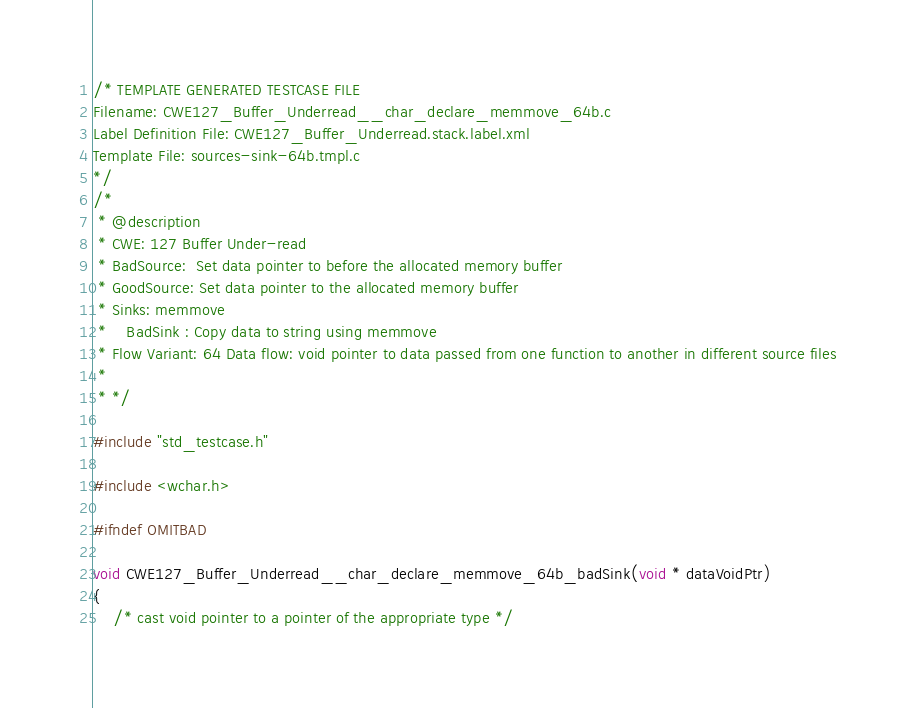<code> <loc_0><loc_0><loc_500><loc_500><_C_>/* TEMPLATE GENERATED TESTCASE FILE
Filename: CWE127_Buffer_Underread__char_declare_memmove_64b.c
Label Definition File: CWE127_Buffer_Underread.stack.label.xml
Template File: sources-sink-64b.tmpl.c
*/
/*
 * @description
 * CWE: 127 Buffer Under-read
 * BadSource:  Set data pointer to before the allocated memory buffer
 * GoodSource: Set data pointer to the allocated memory buffer
 * Sinks: memmove
 *    BadSink : Copy data to string using memmove
 * Flow Variant: 64 Data flow: void pointer to data passed from one function to another in different source files
 *
 * */

#include "std_testcase.h"

#include <wchar.h>

#ifndef OMITBAD

void CWE127_Buffer_Underread__char_declare_memmove_64b_badSink(void * dataVoidPtr)
{
    /* cast void pointer to a pointer of the appropriate type */</code> 